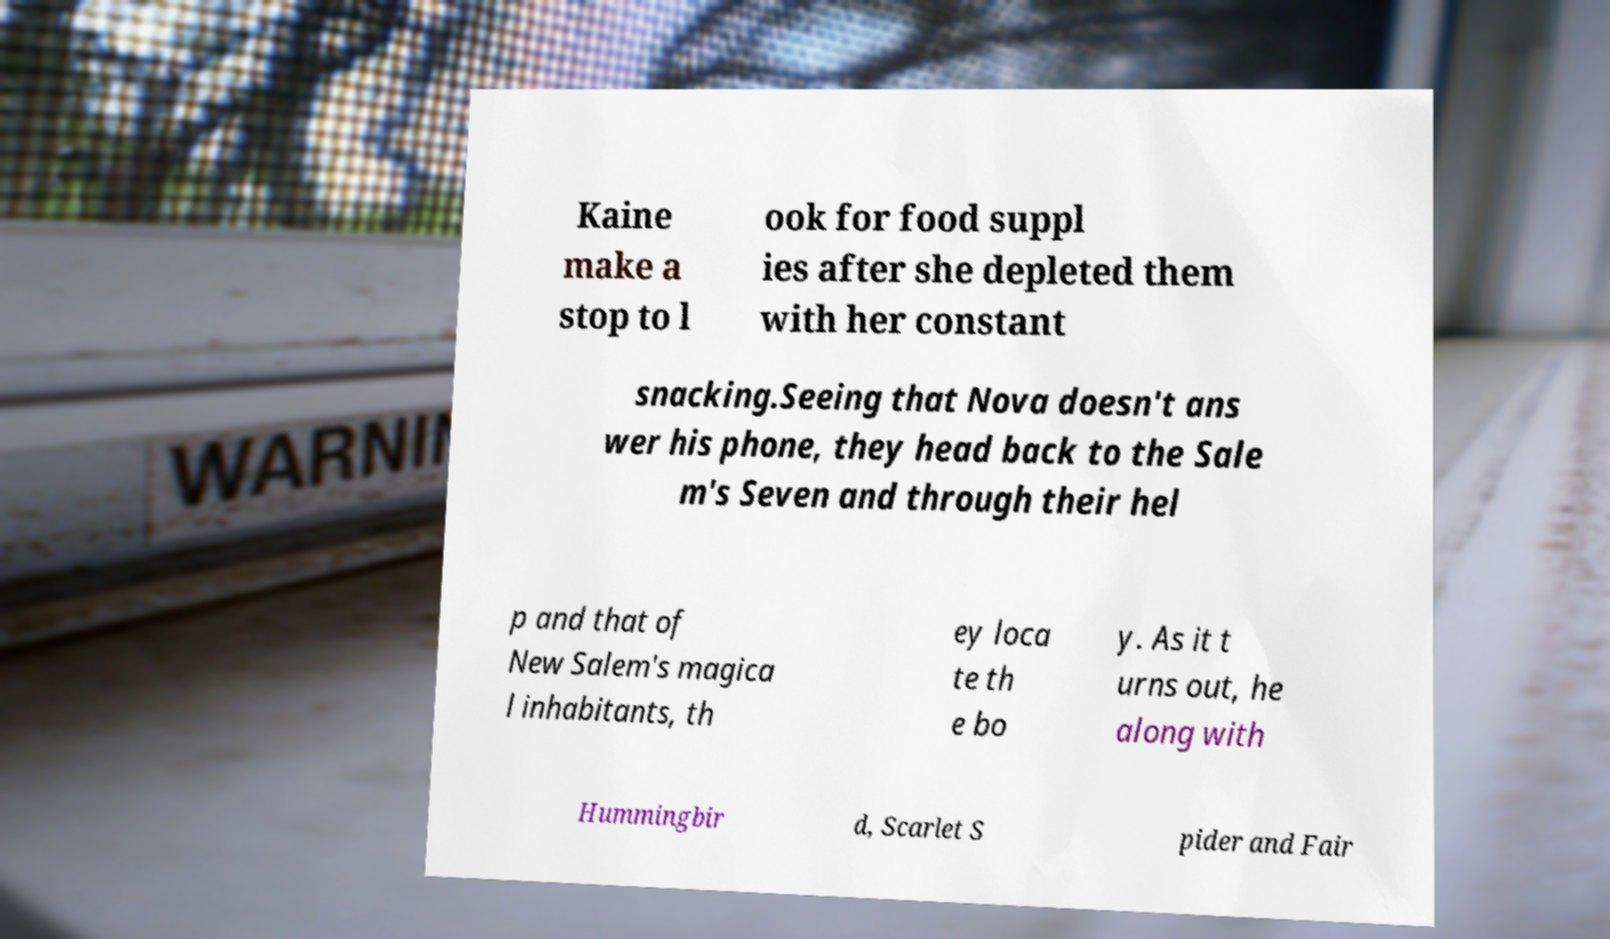Can you read and provide the text displayed in the image?This photo seems to have some interesting text. Can you extract and type it out for me? Kaine make a stop to l ook for food suppl ies after she depleted them with her constant snacking.Seeing that Nova doesn't ans wer his phone, they head back to the Sale m's Seven and through their hel p and that of New Salem's magica l inhabitants, th ey loca te th e bo y. As it t urns out, he along with Hummingbir d, Scarlet S pider and Fair 